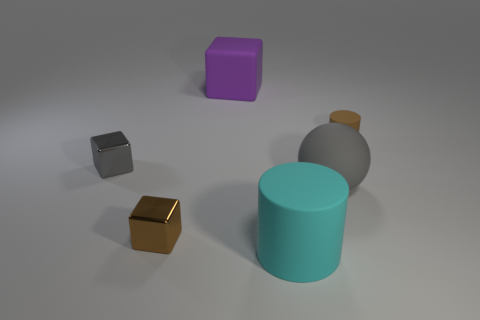How many other objects are there of the same color as the large rubber block?
Your answer should be compact. 0. There is a small object in front of the gray rubber thing; what shape is it?
Keep it short and to the point. Cube. Is the small gray object made of the same material as the small cylinder?
Offer a terse response. No. Are there any other things that have the same size as the brown metallic object?
Provide a succinct answer. Yes. There is a tiny brown matte cylinder; what number of large matte cylinders are behind it?
Provide a short and direct response. 0. The small brown object behind the metal block behind the tiny brown metallic object is what shape?
Offer a terse response. Cylinder. Is there any other thing that is the same shape as the tiny brown shiny thing?
Offer a terse response. Yes. Is the number of small brown metal cubes that are right of the tiny matte cylinder greater than the number of red matte things?
Offer a terse response. No. What number of large objects are to the left of the rubber object that is in front of the small brown shiny thing?
Offer a very short reply. 1. What shape is the brown object that is to the left of the cylinder that is in front of the brown thing that is to the right of the big purple matte thing?
Give a very brief answer. Cube. 